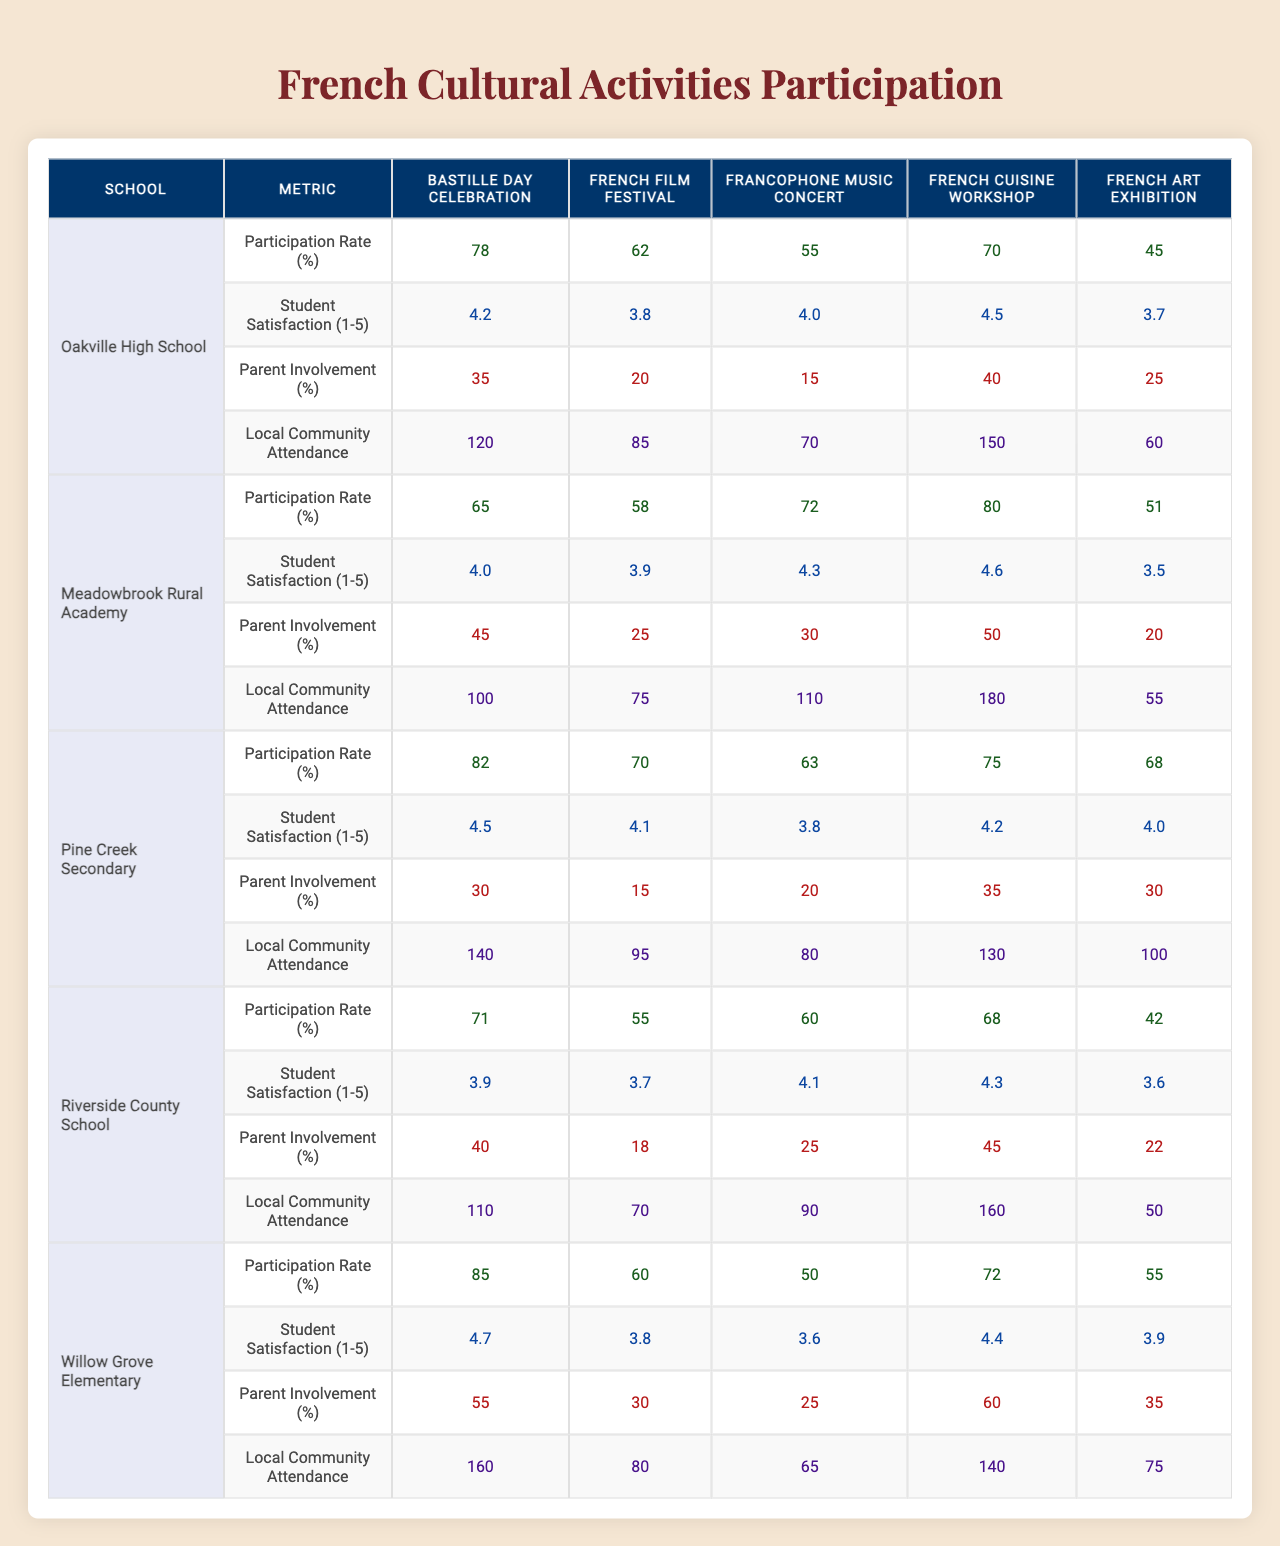What is the participation rate for the French Film Festival at Willow Grove Elementary? The table shows that Willow Grove Elementary has a participation rate of 60% for the French Film Festival.
Answer: 60% What school had the highest participation rate for the Francophone Music Concert? Pine Creek Secondary had the highest participation rate of 63% for the Francophone Music Concert.
Answer: Pine Creek Secondary What is the average student satisfaction score for the French Cuisine Workshop across all schools? The scores for the French Cuisine Workshop are 4.5 (Oakville High), 4.6 (Meadowbrook), 4.2 (Pine Creek), 4.3 (Riverside), and 4.4 (Willow Grove). Adding these gives 4.5 + 4.6 + 4.2 + 4.3 + 4.4 = 22. The average is 22 / 5 = 4.4.
Answer: 4.4 Which event had the lowest participation rate at Riverside County School? Looking at the participation rates for Riverside County School, the lowest rate is 42% for the French Art Exhibition.
Answer: 42% Is the student satisfaction for the Bastille Day Celebration greater than or equal to 4 for all schools? The student satisfaction scores for the Bastille Day Celebration are: 4.2 (Oakville), 4.0 (Meadowbrook), 4.5 (Pine Creek), 3.9 (Riverside), 4.7 (Willow Grove). The score for Riverside County School (3.9) is less than 4, so not all schools have a score of 4 or higher.
Answer: No What is the difference in local community attendance between the French Film Festival and the French Cuisine Workshop at Meadowbrook Rural Academy? Local community attendance for the French Film Festival is 75 and for the French Cuisine Workshop is 180. The difference is 180 - 75 = 105.
Answer: 105 What percentage of parent involvement was higher at Willow Grove Elementary compared to Oakville High School for the French Art Exhibition? Parent involvement for Willow Grove Elementary is 25% and for Oakville High School it is 15%. The difference is 25 - 15 = 10, meaning 10% more parent involvement at Willow Grove Elementary.
Answer: 10% Which school had the lowest average participation rate across all events? To find this, we calculate the average participation rates: Oakville (62), Meadowbrook (65.2), Pine Creek (71.6), Riverside (59.2), and Willow Grove (62). Riverside County School has the lowest average of 59.2%.
Answer: Riverside County School Did Pine Creek Secondary have a higher average satisfaction score than the participation rate for the French Cuisine Workshop? Pine Creek's average satisfaction score is 4.2 and the participation rate for the French Cuisine Workshop is 75%. Comparing them shows that 4.2 satisfies the question's criteria, confirming Pine Creek’s average satisfaction is not straightforwardly comparable to a percentage rate. Thus, we consider numerical comparison with both attributes; satisfaction is explicitly numerical while participation is a percentage without a direct "higher" relationship in basis. Thus we would not account for this definitively.
Answer: No What is the total local community attendance for the Bastille Day Celebration across all schools? The local community attendance for Bastille Day is: 120 (Oakville) + 100 (Meadowbrook) + 140 (Pine Creek) + 110 (Riverside) + 160 (Willow Grove) = 730.
Answer: 730 